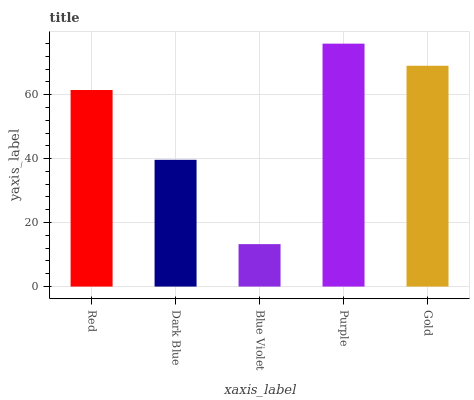Is Dark Blue the minimum?
Answer yes or no. No. Is Dark Blue the maximum?
Answer yes or no. No. Is Red greater than Dark Blue?
Answer yes or no. Yes. Is Dark Blue less than Red?
Answer yes or no. Yes. Is Dark Blue greater than Red?
Answer yes or no. No. Is Red less than Dark Blue?
Answer yes or no. No. Is Red the high median?
Answer yes or no. Yes. Is Red the low median?
Answer yes or no. Yes. Is Dark Blue the high median?
Answer yes or no. No. Is Purple the low median?
Answer yes or no. No. 